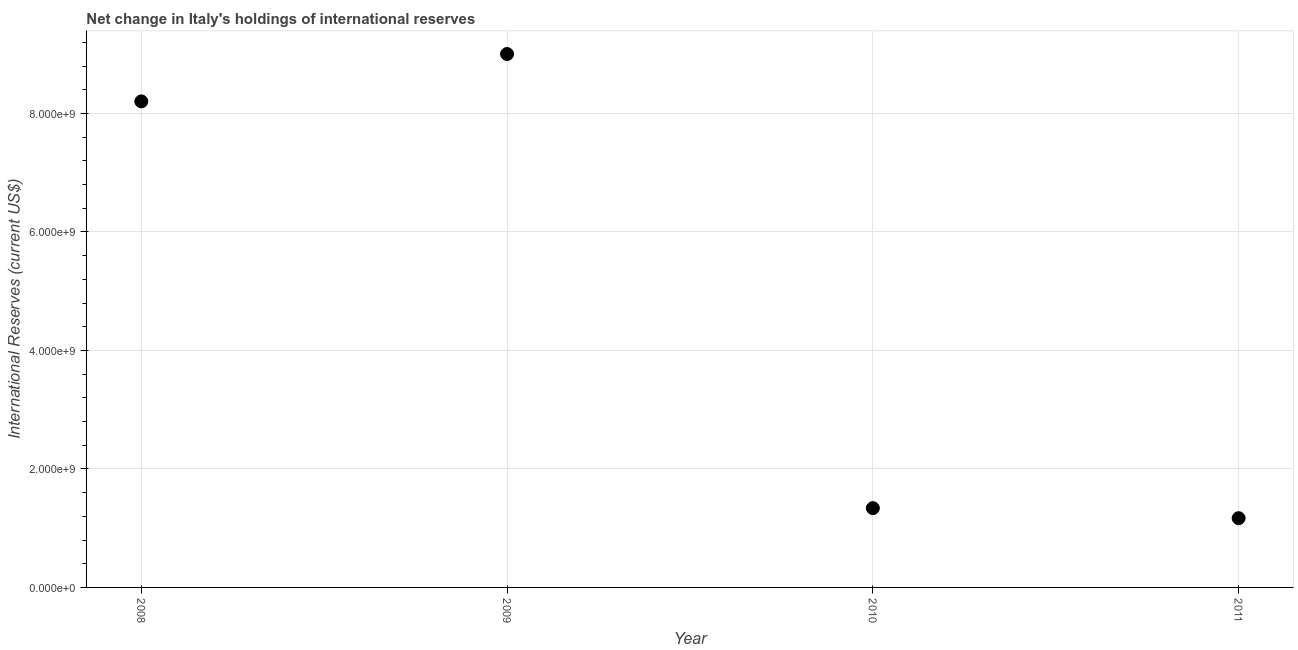What is the reserves and related items in 2011?
Your answer should be very brief. 1.17e+09. Across all years, what is the maximum reserves and related items?
Offer a terse response. 9.00e+09. Across all years, what is the minimum reserves and related items?
Keep it short and to the point. 1.17e+09. What is the sum of the reserves and related items?
Ensure brevity in your answer.  1.97e+1. What is the difference between the reserves and related items in 2008 and 2010?
Your answer should be compact. 6.87e+09. What is the average reserves and related items per year?
Make the answer very short. 4.93e+09. What is the median reserves and related items?
Provide a short and direct response. 4.77e+09. Do a majority of the years between 2009 and 2008 (inclusive) have reserves and related items greater than 3600000000 US$?
Offer a very short reply. No. What is the ratio of the reserves and related items in 2008 to that in 2011?
Provide a short and direct response. 7.02. What is the difference between the highest and the second highest reserves and related items?
Make the answer very short. 7.99e+08. What is the difference between the highest and the lowest reserves and related items?
Provide a succinct answer. 7.83e+09. How many dotlines are there?
Provide a succinct answer. 1. Are the values on the major ticks of Y-axis written in scientific E-notation?
Offer a very short reply. Yes. Does the graph contain grids?
Provide a succinct answer. Yes. What is the title of the graph?
Offer a very short reply. Net change in Italy's holdings of international reserves. What is the label or title of the Y-axis?
Give a very brief answer. International Reserves (current US$). What is the International Reserves (current US$) in 2008?
Give a very brief answer. 8.20e+09. What is the International Reserves (current US$) in 2009?
Your answer should be compact. 9.00e+09. What is the International Reserves (current US$) in 2010?
Give a very brief answer. 1.34e+09. What is the International Reserves (current US$) in 2011?
Provide a succinct answer. 1.17e+09. What is the difference between the International Reserves (current US$) in 2008 and 2009?
Your answer should be compact. -7.99e+08. What is the difference between the International Reserves (current US$) in 2008 and 2010?
Make the answer very short. 6.87e+09. What is the difference between the International Reserves (current US$) in 2008 and 2011?
Offer a terse response. 7.03e+09. What is the difference between the International Reserves (current US$) in 2009 and 2010?
Your response must be concise. 7.66e+09. What is the difference between the International Reserves (current US$) in 2009 and 2011?
Make the answer very short. 7.83e+09. What is the difference between the International Reserves (current US$) in 2010 and 2011?
Ensure brevity in your answer.  1.69e+08. What is the ratio of the International Reserves (current US$) in 2008 to that in 2009?
Keep it short and to the point. 0.91. What is the ratio of the International Reserves (current US$) in 2008 to that in 2010?
Offer a terse response. 6.13. What is the ratio of the International Reserves (current US$) in 2008 to that in 2011?
Ensure brevity in your answer.  7.02. What is the ratio of the International Reserves (current US$) in 2009 to that in 2010?
Your answer should be very brief. 6.73. What is the ratio of the International Reserves (current US$) in 2009 to that in 2011?
Offer a terse response. 7.7. What is the ratio of the International Reserves (current US$) in 2010 to that in 2011?
Ensure brevity in your answer.  1.15. 